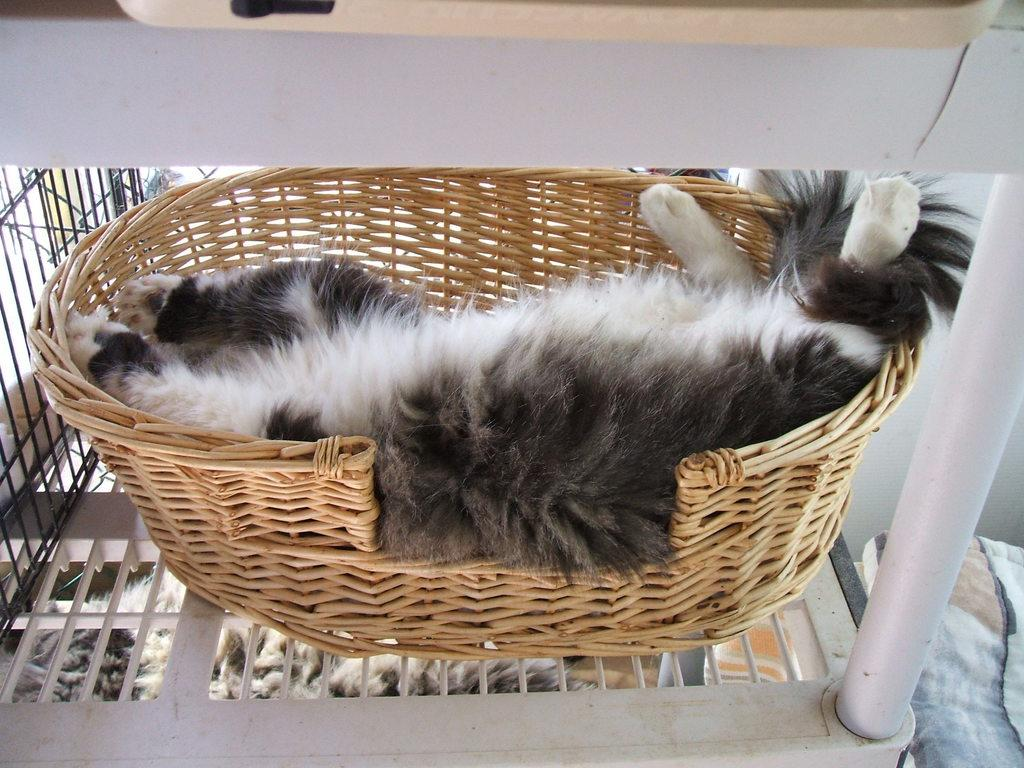What type of animal is present in the image? There is an animal in the image. Where is the animal located in the image? The animal is in a basket. What is the color scheme of the image? The image is in black and white. What type of beast can be seen playing with the son in the image? There is no beast or son present in the image; it only features an animal in a basket. What type of cub is visible in the image? There is no cub present in the image. 